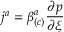<formula> <loc_0><loc_0><loc_500><loc_500>j ^ { a } = \beta _ { \left ( c \right ) } ^ { a } \frac { \partial p } { \partial \xi }</formula> 